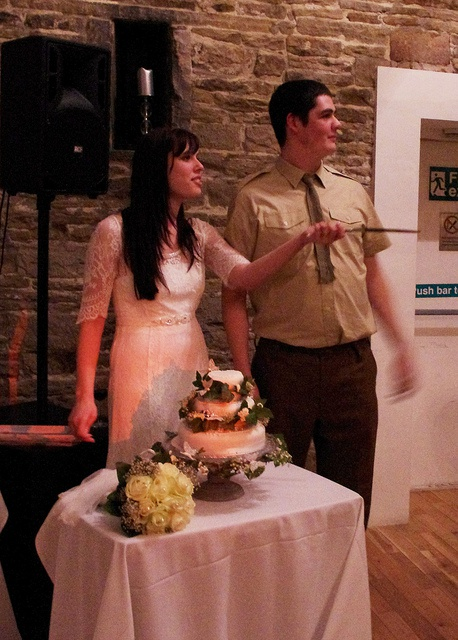Describe the objects in this image and their specific colors. I can see dining table in maroon, brown, and lightpink tones, people in maroon, black, and brown tones, people in maroon, black, brown, and lightpink tones, cake in maroon, salmon, black, and brown tones, and tie in maroon, brown, and black tones in this image. 